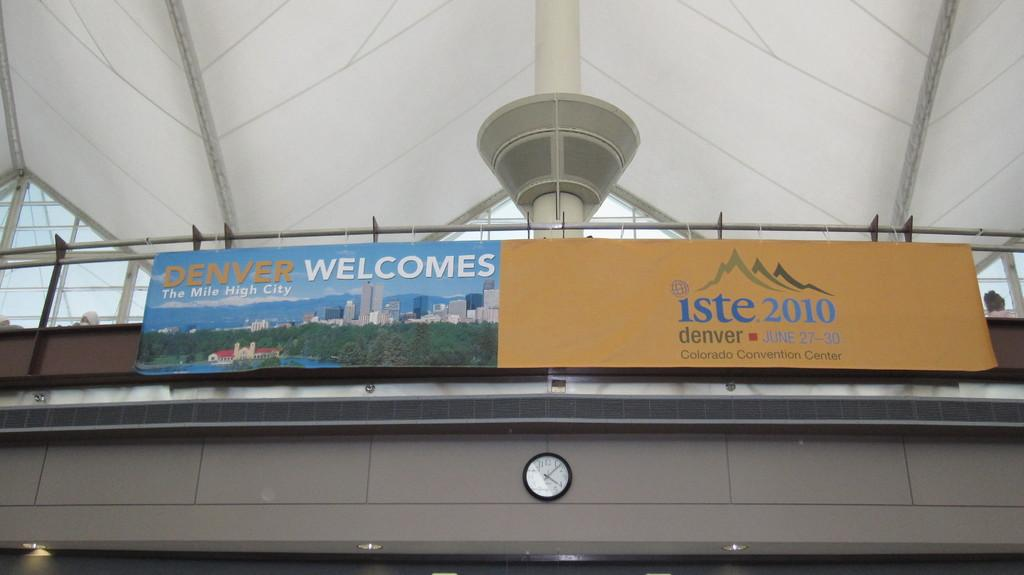<image>
Summarize the visual content of the image. An airport billboard that says "Denver Welcomes: The Mile High City". 